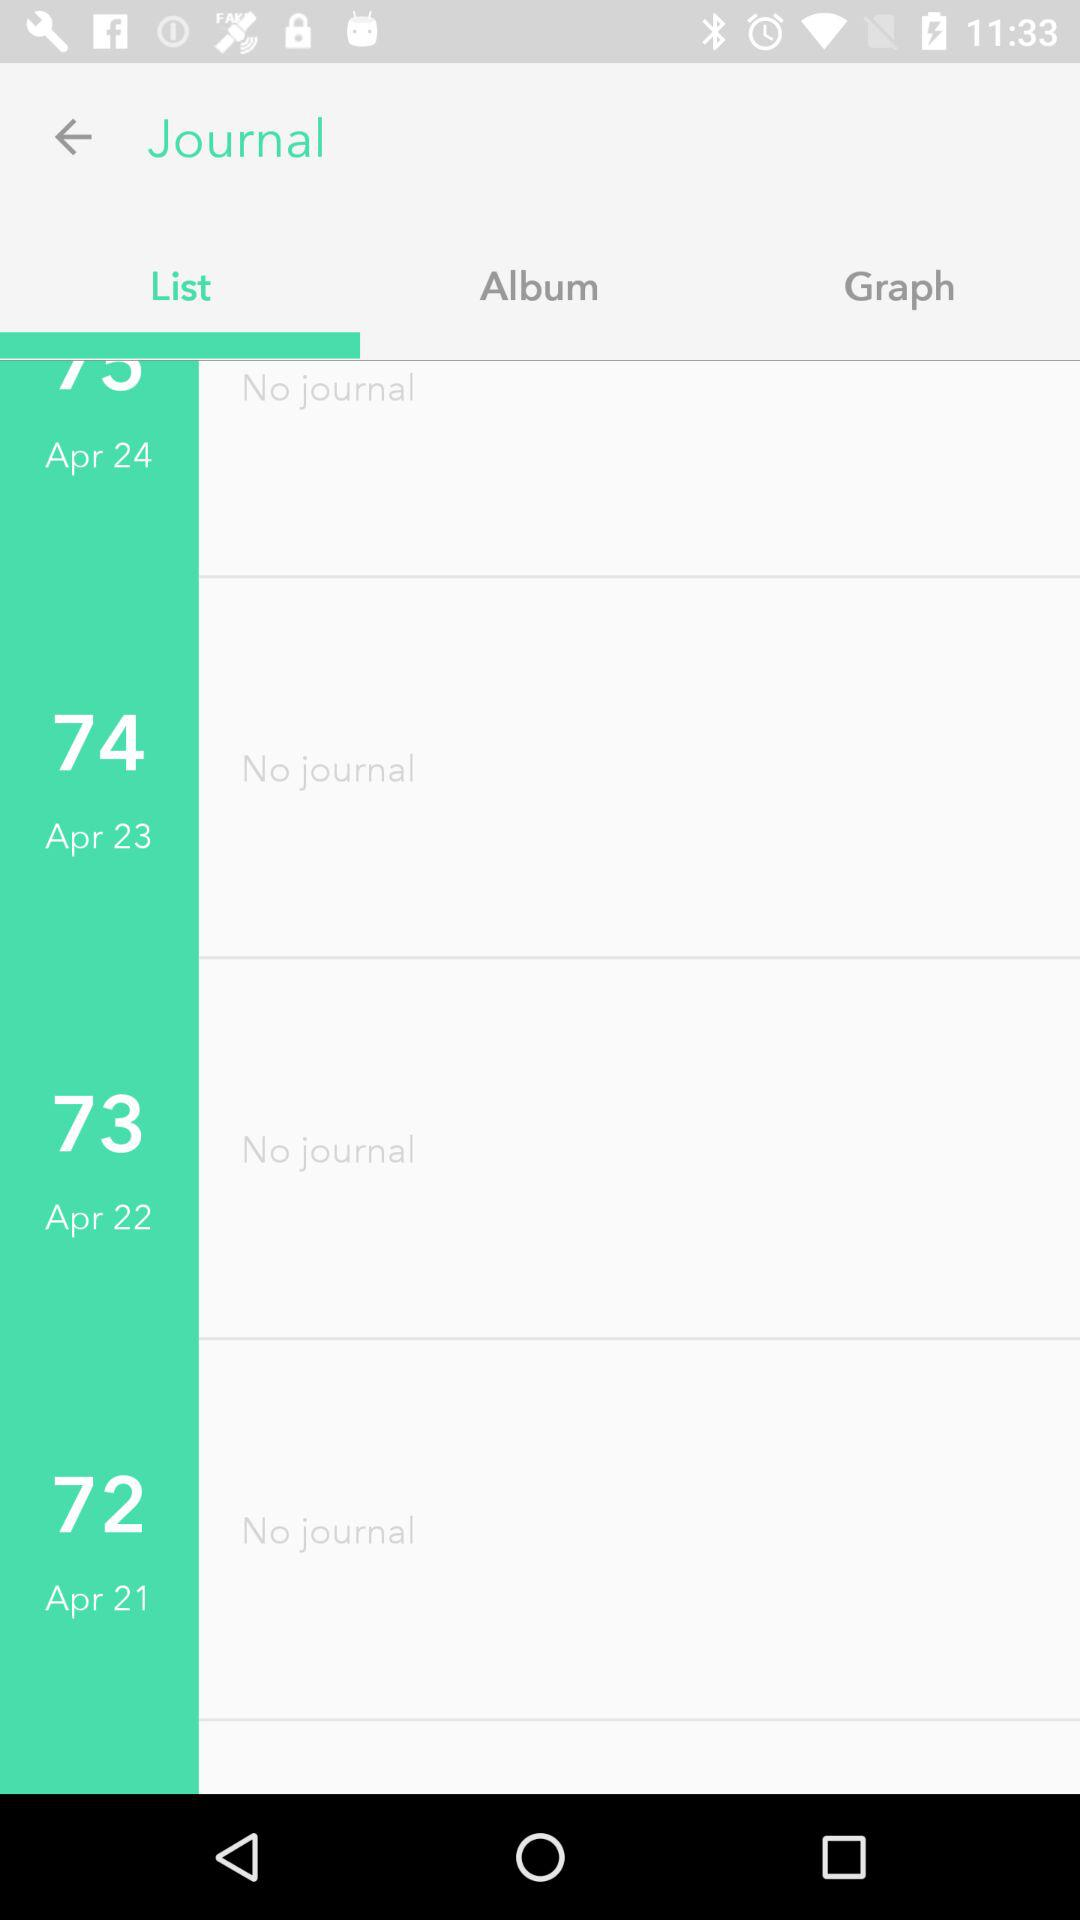Which tab is selected? The selected tab is "List". 